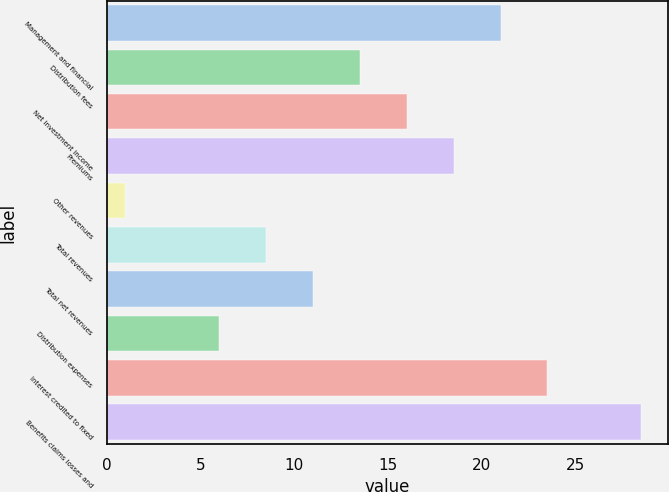Convert chart to OTSL. <chart><loc_0><loc_0><loc_500><loc_500><bar_chart><fcel>Management and financial<fcel>Distribution fees<fcel>Net investment income<fcel>Premiums<fcel>Other revenues<fcel>Total revenues<fcel>Total net revenues<fcel>Distribution expenses<fcel>Interest credited to fixed<fcel>Benefits claims losses and<nl><fcel>21<fcel>13.5<fcel>16<fcel>18.5<fcel>1<fcel>8.5<fcel>11<fcel>6<fcel>23.5<fcel>28.5<nl></chart> 